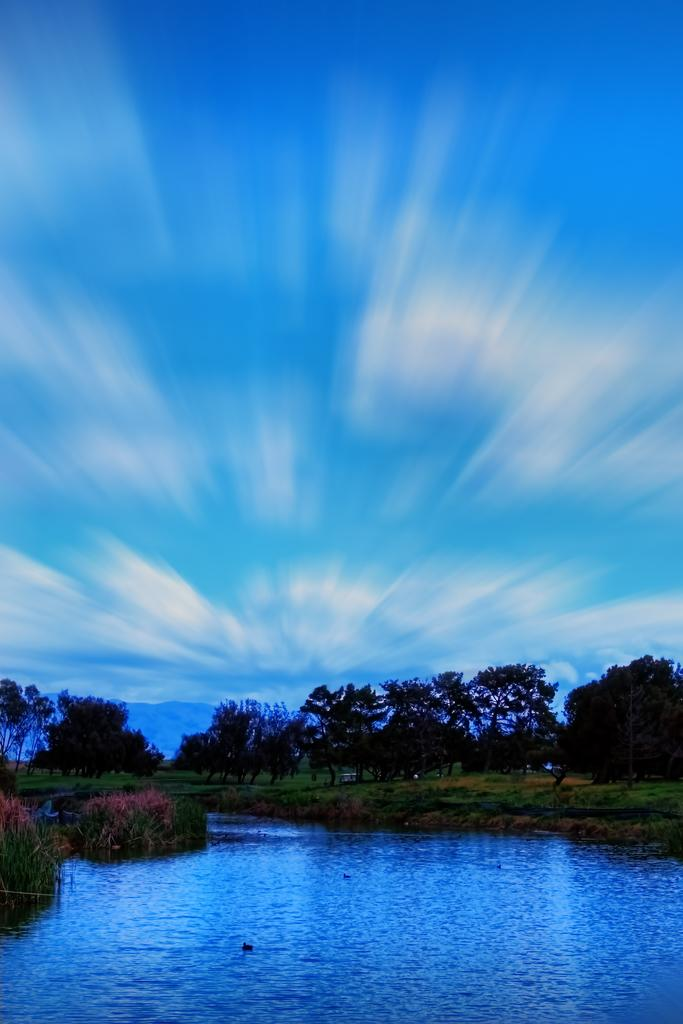What type of vegetation can be seen in the image? There are trees in the image. What geographical feature is visible in the background? There are mountains in the image. What is visible at the top of the image? The sky is visible at the top of the image. What can be seen in the sky? There are clouds in the sky. What type of terrain is present at the bottom of the image? Grass is present at the bottom of the image. What natural feature is visible at the bottom of the image? There is water visible at the bottom of the image. Where is the judge sitting in the image? There is no judge present in the image. What type of cushion is used to support the trees in the image? There are no cushions present in the image; the trees are standing on the ground. 